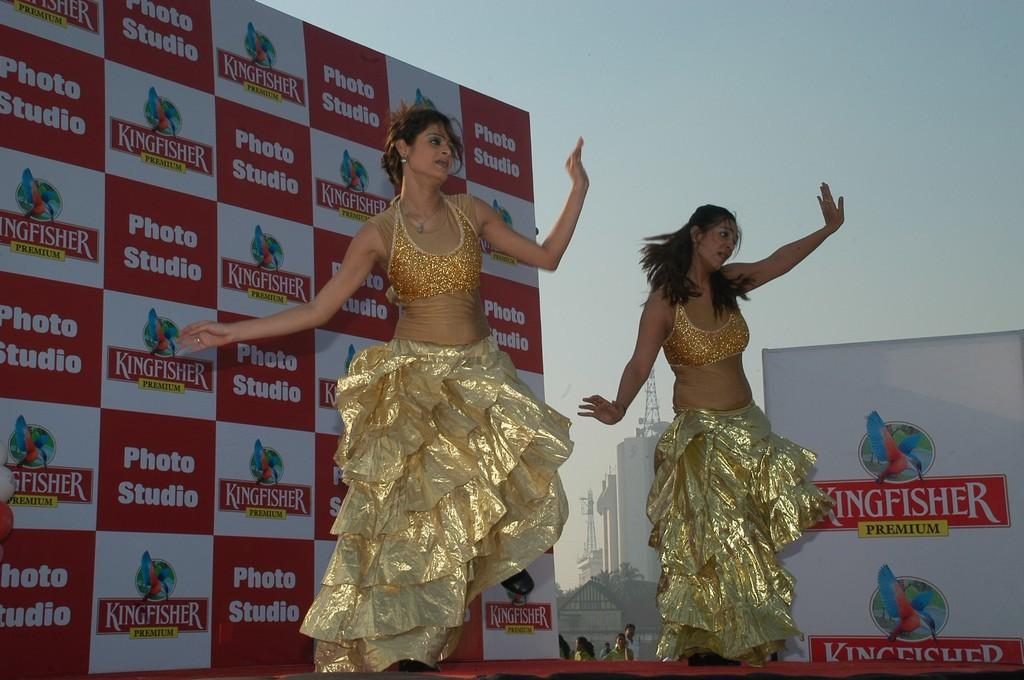What are the two women in the image doing? The two women are dancing in the image. Where are the women dancing? The women are dancing on the floor. What can be seen in the background of the image? In the background of the image, there are hoardings, buildings, towers, people, and the sky. What type of map can be seen on the floor where the women are dancing? There is no map present in the image; the women are dancing on the floor without any map. What business is being conducted in the bedroom visible in the background of the image? There is no bedroom or business visible in the background of the image. 